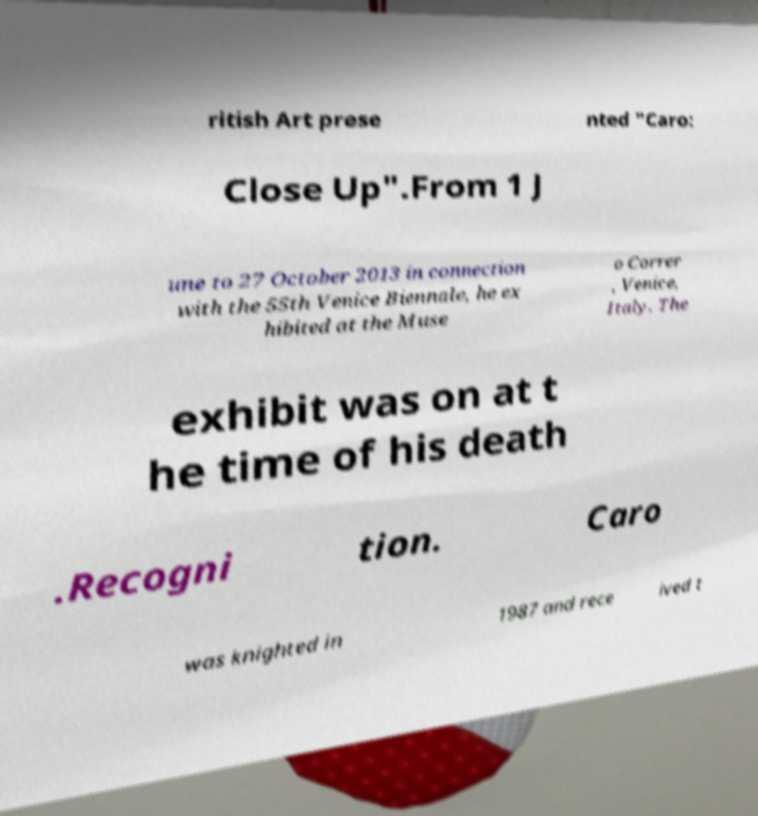Can you read and provide the text displayed in the image?This photo seems to have some interesting text. Can you extract and type it out for me? ritish Art prese nted "Caro: Close Up".From 1 J une to 27 October 2013 in connection with the 55th Venice Biennale, he ex hibited at the Muse o Correr , Venice, Italy. The exhibit was on at t he time of his death .Recogni tion. Caro was knighted in 1987 and rece ived t 